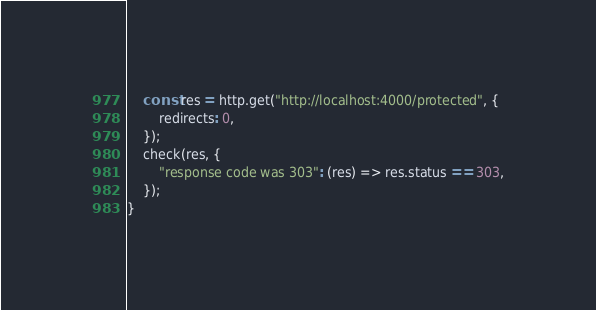<code> <loc_0><loc_0><loc_500><loc_500><_JavaScript_>    const res = http.get("http://localhost:4000/protected", {
        redirects: 0,
    });
    check(res, {
        "response code was 303": (res) => res.status == 303,
    });
}
</code> 